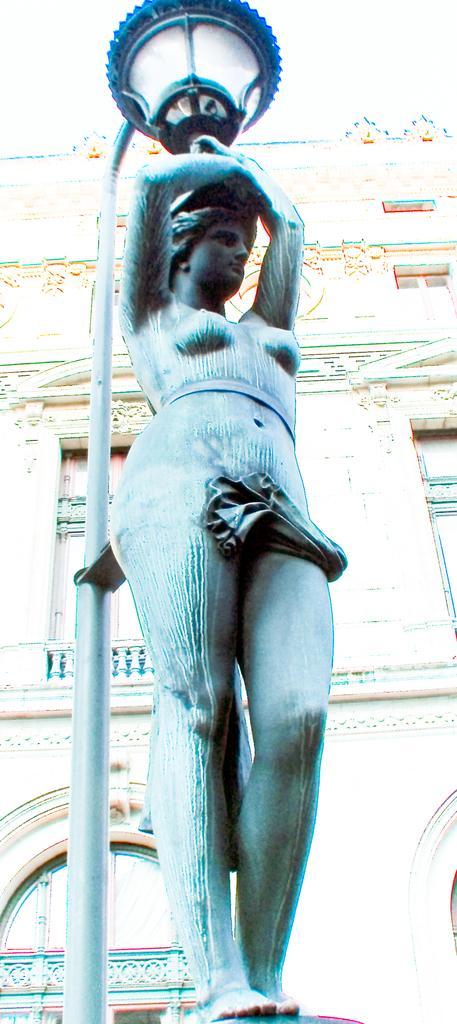Describe this image in one or two sentences. In this image we can see a statue with a light on top of it. In the background, we can see a pole and building with windows. 